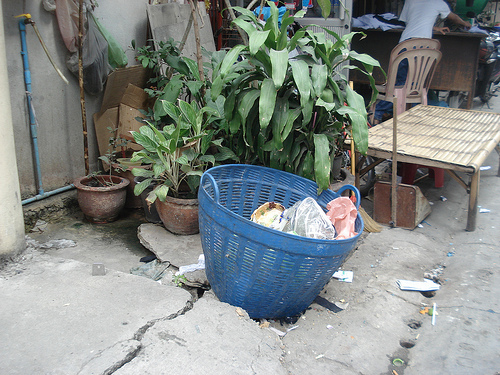<image>
Is there a chair behind the tap? No. The chair is not behind the tap. From this viewpoint, the chair appears to be positioned elsewhere in the scene. 